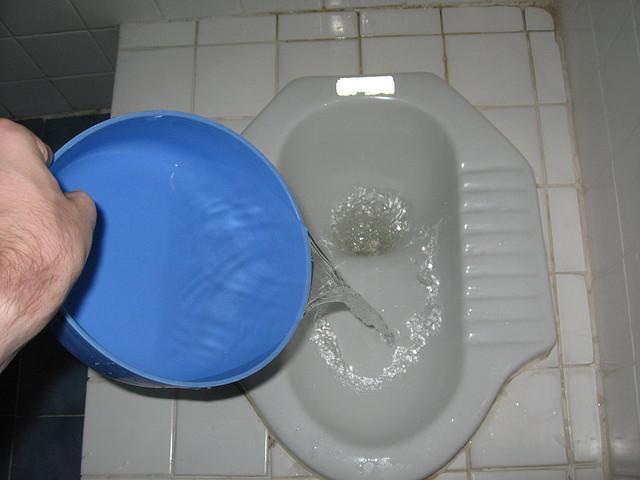Is the statement "The person is touching the bowl." accurate regarding the image?
Answer yes or no. Yes. 